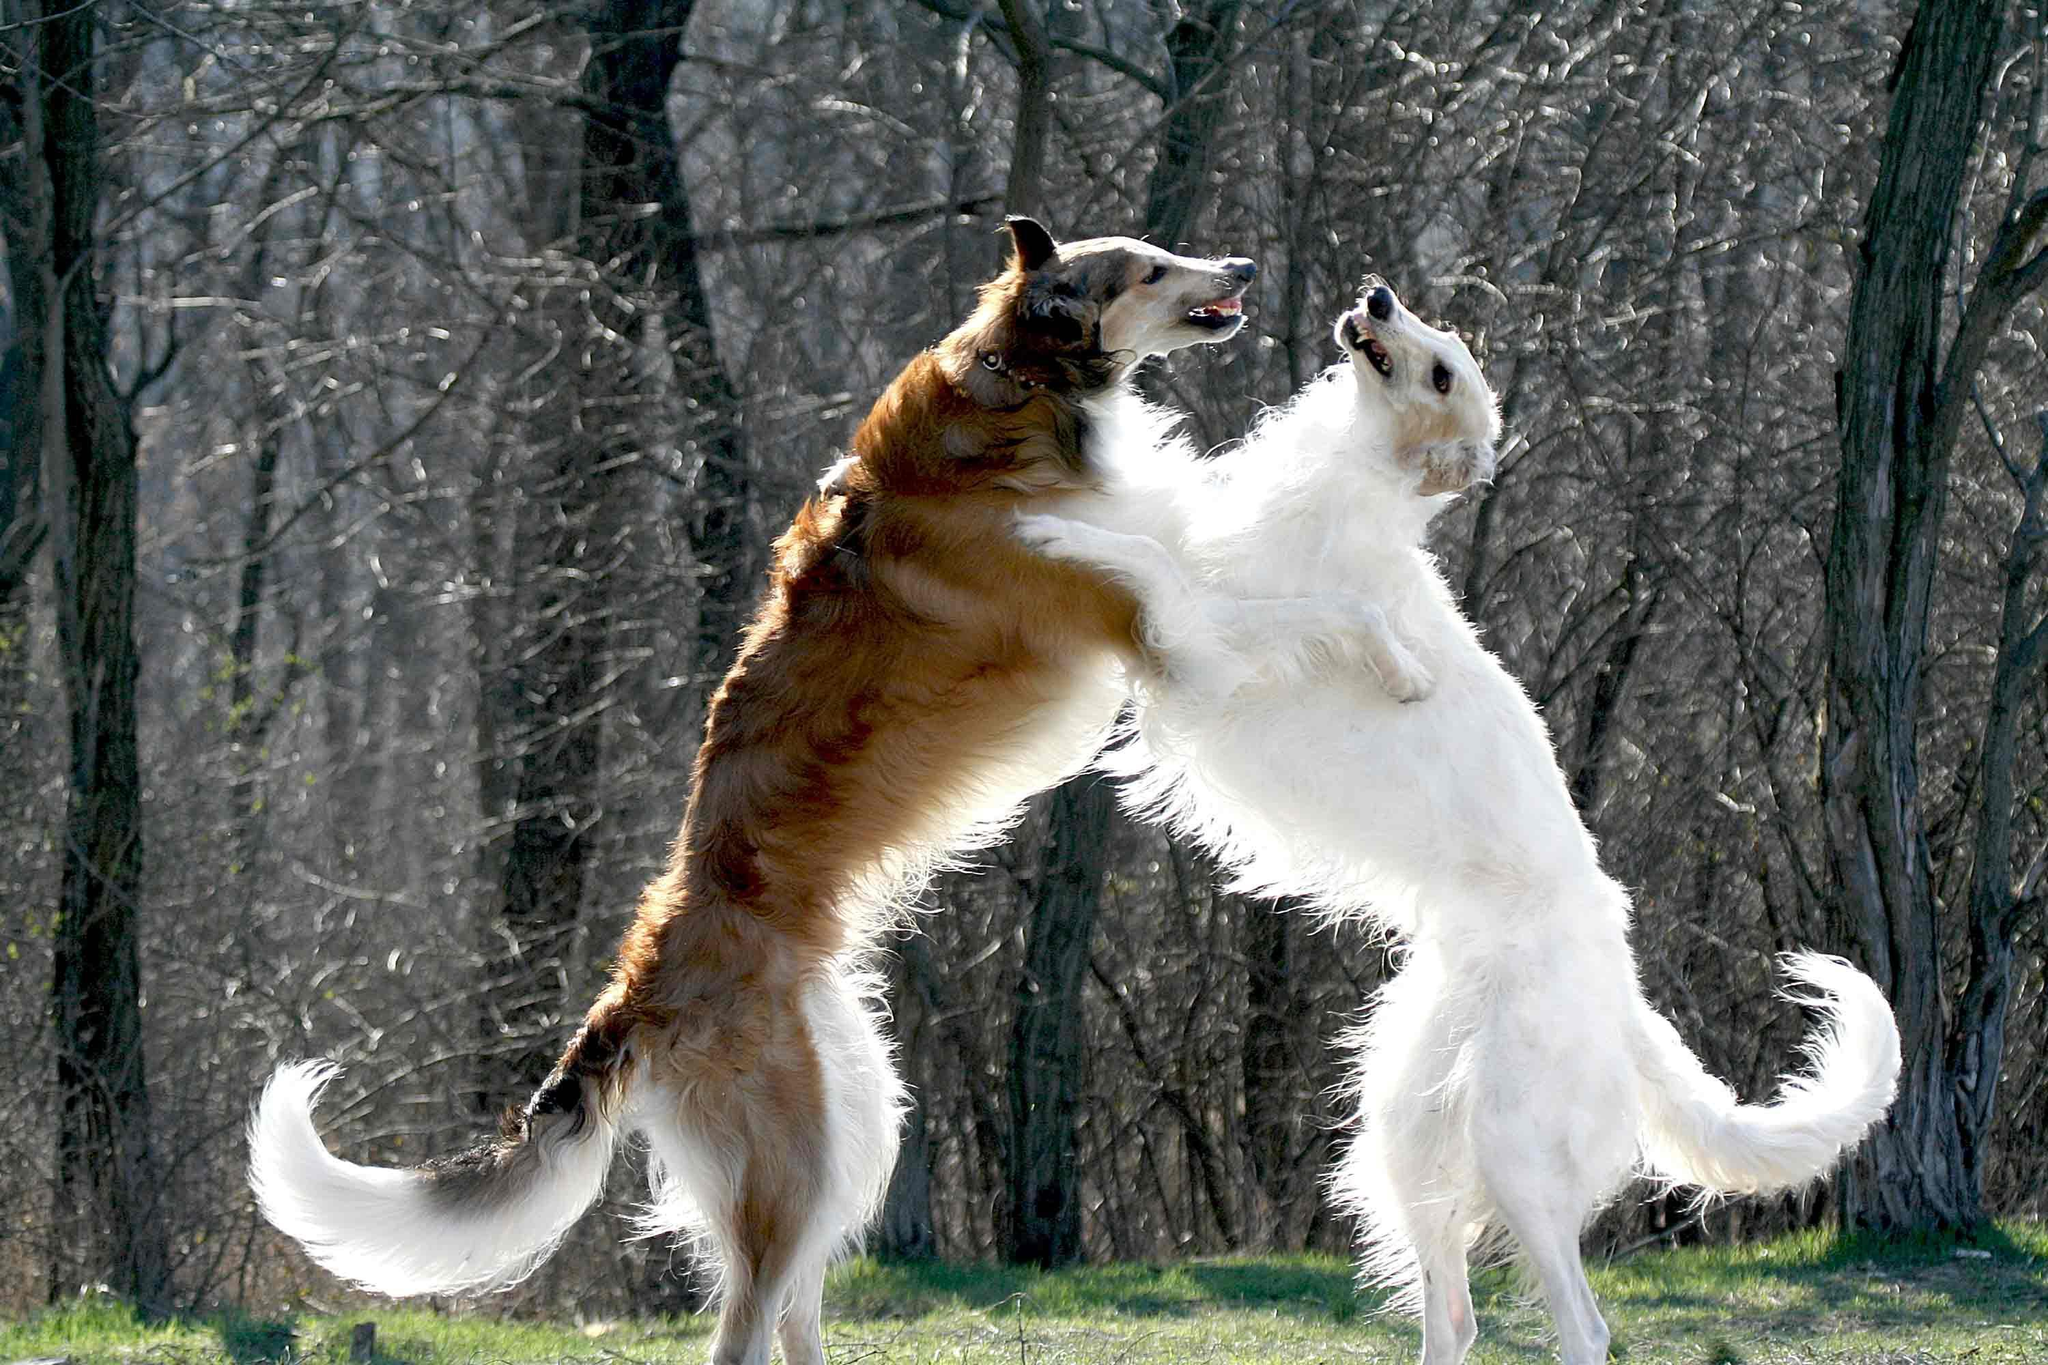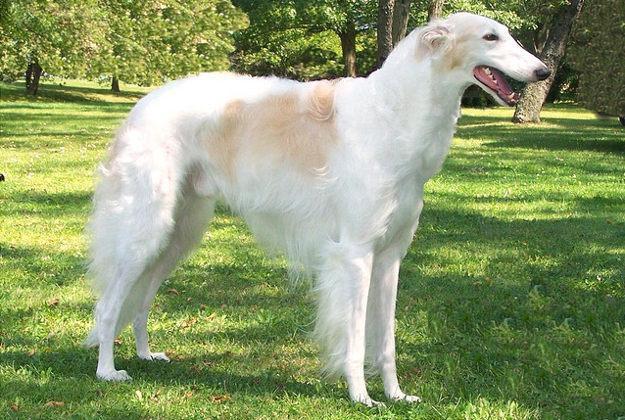The first image is the image on the left, the second image is the image on the right. Given the left and right images, does the statement "There are more dogs outside in the image on the right." hold true? Answer yes or no. No. The first image is the image on the left, the second image is the image on the right. For the images displayed, is the sentence "The lefthand image contains one gray-and-white hound standing with its body turned leftward and face to the camera." factually correct? Answer yes or no. No. 